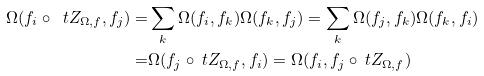<formula> <loc_0><loc_0><loc_500><loc_500>\Omega ( f _ { i } \circ \ t Z _ { \Omega , { f } } , f _ { j } ) = & \sum _ { k } \Omega ( f _ { i } , f _ { k } ) \Omega ( f _ { k } , f _ { j } ) = \sum _ { k } \Omega ( f _ { j } , f _ { k } ) \Omega ( f _ { k } , f _ { i } ) \\ = & \Omega ( f _ { j } \circ \ t Z _ { \Omega , { f } } , f _ { i } ) = \Omega ( f _ { i } , f _ { j } \circ \ t Z _ { \Omega , { f } } )</formula> 